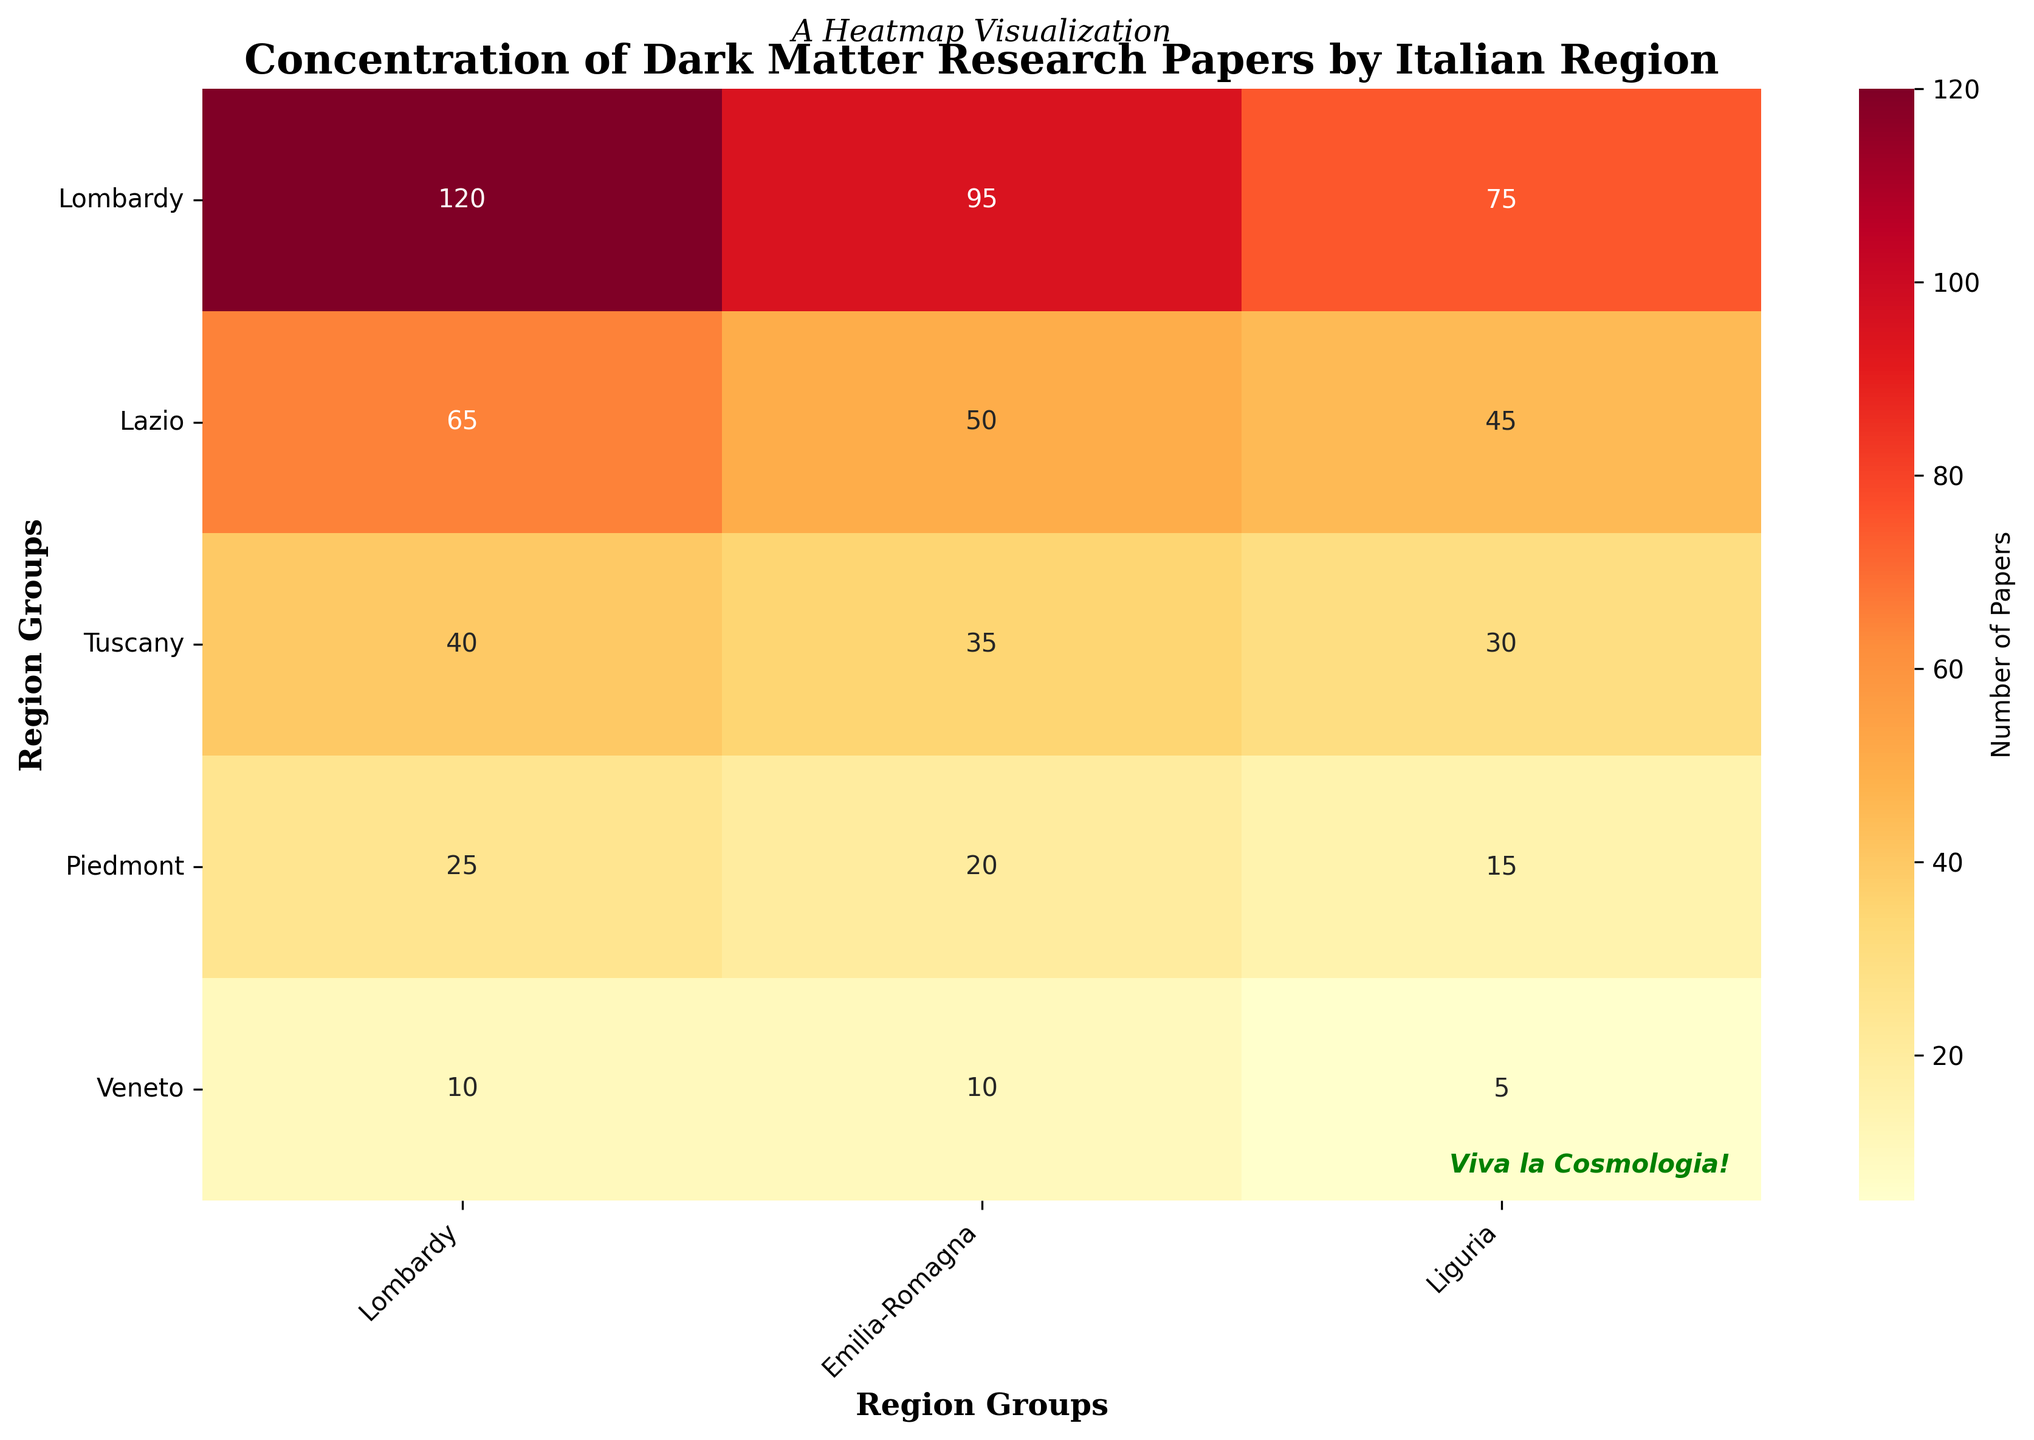What's the title of the heatmap? The title is located at the top of the heatmap. It is typically in bold and a larger font size.
Answer: Concentration of Dark Matter Research Papers by Italian Region Which region has the highest number of dark matter research papers? The highest value in the heatmap corresponds to the region with the highest number of papers.
Answer: Lombardy How many papers have been published by Lazio and Tuscany combined? Lazio and Tuscany are separate entries on the heatmap. You need to identify their values and add them together: 95 (Lazio) + 75 (Tuscany).
Answer: 170 Which region group has the lowest count of papers? The lowest value in the heatmap represents the region group with the fewest papers.
Answer: Umbria Is the number of papers in Veneto more than in Emilia-Romagna? Compare the values for Veneto and Emilia-Romagna in the heatmap to determine which is larger.
Answer: Yes What's the range of the number of papers published across all regions? To find the range, subtract the smallest value in the heatmap from the largest value. The largest is 120 (Lombardy) and the smallest is 5 (Umbria).
Answer: 115 Which two regions have the closest number of publications? Identify the values in the heatmap that are numerically closest. Tuscany (75) and Piedmont (65) have a difference of 10, which is the smallest difference.
Answer: Tuscany and Piedmont By how much does the number of papers in Campania exceed that in Apulia? Subtract the number of papers in Apulia from that in Campania: 40 (Campania) - 30 (Apulia).
Answer: 10 How many regions have published more than 50 papers? Count the number of regions in the heatmap with values above 50. There are four: Lombardy (120), Lazio (95), Tuscany (75), and Piedmont (65).
Answer: 4 